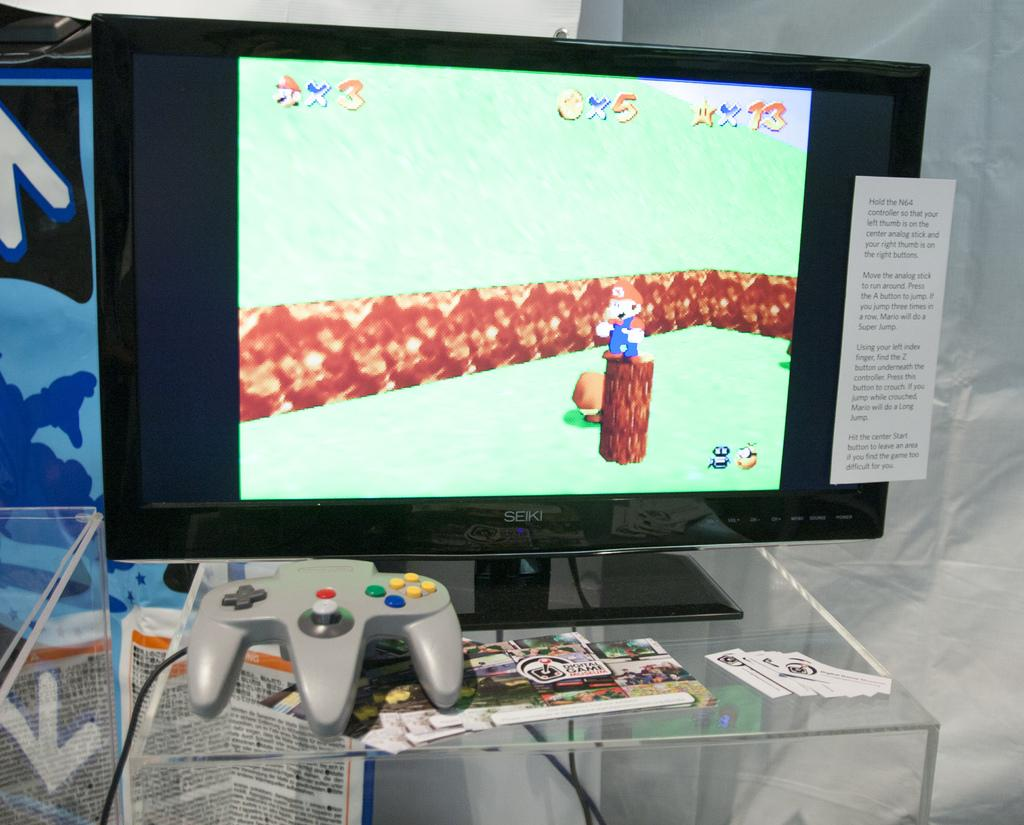<image>
Offer a succinct explanation of the picture presented. a computer monitor with a picture of a  face and x3 on the top left corner. 